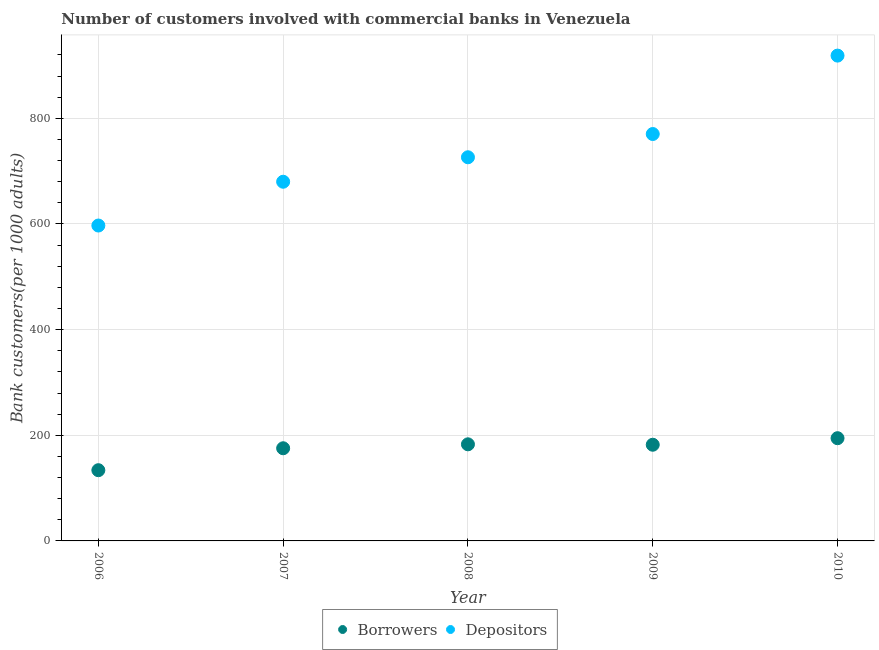Is the number of dotlines equal to the number of legend labels?
Make the answer very short. Yes. What is the number of depositors in 2006?
Your response must be concise. 597.09. Across all years, what is the maximum number of depositors?
Keep it short and to the point. 918.79. Across all years, what is the minimum number of borrowers?
Provide a succinct answer. 133.89. In which year was the number of borrowers minimum?
Keep it short and to the point. 2006. What is the total number of borrowers in the graph?
Keep it short and to the point. 868.78. What is the difference between the number of depositors in 2007 and that in 2010?
Provide a short and direct response. -238.8. What is the difference between the number of borrowers in 2008 and the number of depositors in 2009?
Keep it short and to the point. -587.45. What is the average number of depositors per year?
Your answer should be compact. 738.51. In the year 2010, what is the difference between the number of depositors and number of borrowers?
Your answer should be very brief. 724.31. What is the ratio of the number of depositors in 2007 to that in 2008?
Offer a very short reply. 0.94. Is the number of borrowers in 2009 less than that in 2010?
Offer a very short reply. Yes. Is the difference between the number of depositors in 2007 and 2008 greater than the difference between the number of borrowers in 2007 and 2008?
Ensure brevity in your answer.  No. What is the difference between the highest and the second highest number of borrowers?
Ensure brevity in your answer.  11.59. What is the difference between the highest and the lowest number of depositors?
Provide a short and direct response. 321.7. In how many years, is the number of depositors greater than the average number of depositors taken over all years?
Your answer should be very brief. 2. Is the sum of the number of depositors in 2009 and 2010 greater than the maximum number of borrowers across all years?
Provide a short and direct response. Yes. Does the graph contain any zero values?
Your response must be concise. No. Where does the legend appear in the graph?
Your answer should be very brief. Bottom center. What is the title of the graph?
Make the answer very short. Number of customers involved with commercial banks in Venezuela. Does "Exports" appear as one of the legend labels in the graph?
Your answer should be very brief. No. What is the label or title of the Y-axis?
Keep it short and to the point. Bank customers(per 1000 adults). What is the Bank customers(per 1000 adults) of Borrowers in 2006?
Ensure brevity in your answer.  133.89. What is the Bank customers(per 1000 adults) of Depositors in 2006?
Offer a very short reply. 597.09. What is the Bank customers(per 1000 adults) of Borrowers in 2007?
Your answer should be compact. 175.43. What is the Bank customers(per 1000 adults) of Depositors in 2007?
Make the answer very short. 679.99. What is the Bank customers(per 1000 adults) of Borrowers in 2008?
Provide a short and direct response. 182.89. What is the Bank customers(per 1000 adults) in Depositors in 2008?
Make the answer very short. 726.32. What is the Bank customers(per 1000 adults) of Borrowers in 2009?
Your response must be concise. 182.09. What is the Bank customers(per 1000 adults) of Depositors in 2009?
Make the answer very short. 770.33. What is the Bank customers(per 1000 adults) of Borrowers in 2010?
Keep it short and to the point. 194.48. What is the Bank customers(per 1000 adults) in Depositors in 2010?
Offer a very short reply. 918.79. Across all years, what is the maximum Bank customers(per 1000 adults) in Borrowers?
Ensure brevity in your answer.  194.48. Across all years, what is the maximum Bank customers(per 1000 adults) of Depositors?
Provide a succinct answer. 918.79. Across all years, what is the minimum Bank customers(per 1000 adults) of Borrowers?
Provide a short and direct response. 133.89. Across all years, what is the minimum Bank customers(per 1000 adults) in Depositors?
Offer a terse response. 597.09. What is the total Bank customers(per 1000 adults) in Borrowers in the graph?
Offer a very short reply. 868.78. What is the total Bank customers(per 1000 adults) in Depositors in the graph?
Your answer should be very brief. 3692.53. What is the difference between the Bank customers(per 1000 adults) of Borrowers in 2006 and that in 2007?
Your response must be concise. -41.54. What is the difference between the Bank customers(per 1000 adults) in Depositors in 2006 and that in 2007?
Your answer should be compact. -82.9. What is the difference between the Bank customers(per 1000 adults) in Borrowers in 2006 and that in 2008?
Make the answer very short. -48.99. What is the difference between the Bank customers(per 1000 adults) of Depositors in 2006 and that in 2008?
Your answer should be very brief. -129.23. What is the difference between the Bank customers(per 1000 adults) of Borrowers in 2006 and that in 2009?
Offer a very short reply. -48.19. What is the difference between the Bank customers(per 1000 adults) in Depositors in 2006 and that in 2009?
Offer a very short reply. -173.24. What is the difference between the Bank customers(per 1000 adults) of Borrowers in 2006 and that in 2010?
Give a very brief answer. -60.58. What is the difference between the Bank customers(per 1000 adults) of Depositors in 2006 and that in 2010?
Your response must be concise. -321.7. What is the difference between the Bank customers(per 1000 adults) in Borrowers in 2007 and that in 2008?
Ensure brevity in your answer.  -7.45. What is the difference between the Bank customers(per 1000 adults) in Depositors in 2007 and that in 2008?
Keep it short and to the point. -46.33. What is the difference between the Bank customers(per 1000 adults) in Borrowers in 2007 and that in 2009?
Your answer should be compact. -6.65. What is the difference between the Bank customers(per 1000 adults) in Depositors in 2007 and that in 2009?
Offer a very short reply. -90.34. What is the difference between the Bank customers(per 1000 adults) of Borrowers in 2007 and that in 2010?
Keep it short and to the point. -19.04. What is the difference between the Bank customers(per 1000 adults) of Depositors in 2007 and that in 2010?
Give a very brief answer. -238.8. What is the difference between the Bank customers(per 1000 adults) of Depositors in 2008 and that in 2009?
Your answer should be compact. -44.02. What is the difference between the Bank customers(per 1000 adults) in Borrowers in 2008 and that in 2010?
Offer a very short reply. -11.59. What is the difference between the Bank customers(per 1000 adults) of Depositors in 2008 and that in 2010?
Your response must be concise. -192.47. What is the difference between the Bank customers(per 1000 adults) in Borrowers in 2009 and that in 2010?
Offer a terse response. -12.39. What is the difference between the Bank customers(per 1000 adults) in Depositors in 2009 and that in 2010?
Give a very brief answer. -148.45. What is the difference between the Bank customers(per 1000 adults) of Borrowers in 2006 and the Bank customers(per 1000 adults) of Depositors in 2007?
Your answer should be very brief. -546.1. What is the difference between the Bank customers(per 1000 adults) of Borrowers in 2006 and the Bank customers(per 1000 adults) of Depositors in 2008?
Give a very brief answer. -592.42. What is the difference between the Bank customers(per 1000 adults) in Borrowers in 2006 and the Bank customers(per 1000 adults) in Depositors in 2009?
Give a very brief answer. -636.44. What is the difference between the Bank customers(per 1000 adults) in Borrowers in 2006 and the Bank customers(per 1000 adults) in Depositors in 2010?
Provide a succinct answer. -784.89. What is the difference between the Bank customers(per 1000 adults) in Borrowers in 2007 and the Bank customers(per 1000 adults) in Depositors in 2008?
Your response must be concise. -550.89. What is the difference between the Bank customers(per 1000 adults) of Borrowers in 2007 and the Bank customers(per 1000 adults) of Depositors in 2009?
Offer a terse response. -594.9. What is the difference between the Bank customers(per 1000 adults) in Borrowers in 2007 and the Bank customers(per 1000 adults) in Depositors in 2010?
Make the answer very short. -743.36. What is the difference between the Bank customers(per 1000 adults) in Borrowers in 2008 and the Bank customers(per 1000 adults) in Depositors in 2009?
Offer a very short reply. -587.45. What is the difference between the Bank customers(per 1000 adults) in Borrowers in 2008 and the Bank customers(per 1000 adults) in Depositors in 2010?
Provide a succinct answer. -735.9. What is the difference between the Bank customers(per 1000 adults) in Borrowers in 2009 and the Bank customers(per 1000 adults) in Depositors in 2010?
Provide a short and direct response. -736.7. What is the average Bank customers(per 1000 adults) of Borrowers per year?
Offer a very short reply. 173.76. What is the average Bank customers(per 1000 adults) in Depositors per year?
Make the answer very short. 738.51. In the year 2006, what is the difference between the Bank customers(per 1000 adults) in Borrowers and Bank customers(per 1000 adults) in Depositors?
Keep it short and to the point. -463.2. In the year 2007, what is the difference between the Bank customers(per 1000 adults) in Borrowers and Bank customers(per 1000 adults) in Depositors?
Provide a succinct answer. -504.56. In the year 2008, what is the difference between the Bank customers(per 1000 adults) of Borrowers and Bank customers(per 1000 adults) of Depositors?
Your answer should be compact. -543.43. In the year 2009, what is the difference between the Bank customers(per 1000 adults) of Borrowers and Bank customers(per 1000 adults) of Depositors?
Give a very brief answer. -588.25. In the year 2010, what is the difference between the Bank customers(per 1000 adults) in Borrowers and Bank customers(per 1000 adults) in Depositors?
Offer a very short reply. -724.31. What is the ratio of the Bank customers(per 1000 adults) of Borrowers in 2006 to that in 2007?
Offer a very short reply. 0.76. What is the ratio of the Bank customers(per 1000 adults) of Depositors in 2006 to that in 2007?
Make the answer very short. 0.88. What is the ratio of the Bank customers(per 1000 adults) in Borrowers in 2006 to that in 2008?
Your response must be concise. 0.73. What is the ratio of the Bank customers(per 1000 adults) of Depositors in 2006 to that in 2008?
Ensure brevity in your answer.  0.82. What is the ratio of the Bank customers(per 1000 adults) of Borrowers in 2006 to that in 2009?
Give a very brief answer. 0.74. What is the ratio of the Bank customers(per 1000 adults) in Depositors in 2006 to that in 2009?
Keep it short and to the point. 0.78. What is the ratio of the Bank customers(per 1000 adults) in Borrowers in 2006 to that in 2010?
Provide a short and direct response. 0.69. What is the ratio of the Bank customers(per 1000 adults) in Depositors in 2006 to that in 2010?
Provide a short and direct response. 0.65. What is the ratio of the Bank customers(per 1000 adults) in Borrowers in 2007 to that in 2008?
Offer a very short reply. 0.96. What is the ratio of the Bank customers(per 1000 adults) in Depositors in 2007 to that in 2008?
Your answer should be very brief. 0.94. What is the ratio of the Bank customers(per 1000 adults) in Borrowers in 2007 to that in 2009?
Your answer should be compact. 0.96. What is the ratio of the Bank customers(per 1000 adults) in Depositors in 2007 to that in 2009?
Offer a very short reply. 0.88. What is the ratio of the Bank customers(per 1000 adults) of Borrowers in 2007 to that in 2010?
Offer a terse response. 0.9. What is the ratio of the Bank customers(per 1000 adults) in Depositors in 2007 to that in 2010?
Ensure brevity in your answer.  0.74. What is the ratio of the Bank customers(per 1000 adults) of Depositors in 2008 to that in 2009?
Your response must be concise. 0.94. What is the ratio of the Bank customers(per 1000 adults) in Borrowers in 2008 to that in 2010?
Your answer should be very brief. 0.94. What is the ratio of the Bank customers(per 1000 adults) in Depositors in 2008 to that in 2010?
Give a very brief answer. 0.79. What is the ratio of the Bank customers(per 1000 adults) of Borrowers in 2009 to that in 2010?
Offer a very short reply. 0.94. What is the ratio of the Bank customers(per 1000 adults) of Depositors in 2009 to that in 2010?
Offer a very short reply. 0.84. What is the difference between the highest and the second highest Bank customers(per 1000 adults) in Borrowers?
Offer a terse response. 11.59. What is the difference between the highest and the second highest Bank customers(per 1000 adults) of Depositors?
Provide a short and direct response. 148.45. What is the difference between the highest and the lowest Bank customers(per 1000 adults) of Borrowers?
Give a very brief answer. 60.58. What is the difference between the highest and the lowest Bank customers(per 1000 adults) in Depositors?
Give a very brief answer. 321.7. 